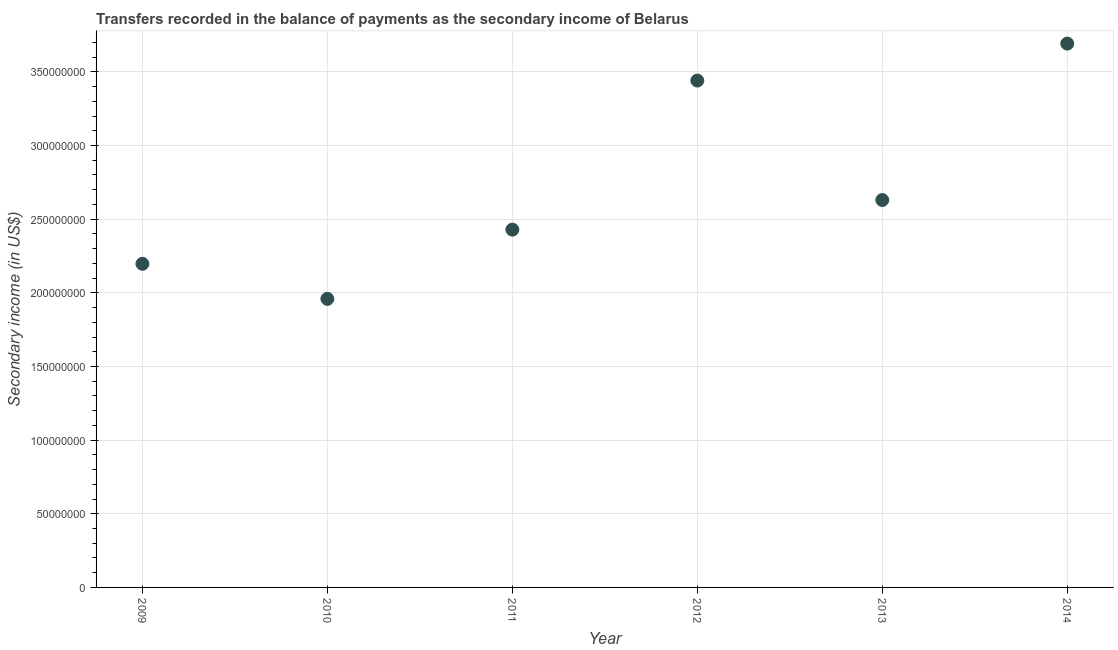What is the amount of secondary income in 2009?
Your answer should be compact. 2.20e+08. Across all years, what is the maximum amount of secondary income?
Give a very brief answer. 3.69e+08. Across all years, what is the minimum amount of secondary income?
Your answer should be compact. 1.96e+08. In which year was the amount of secondary income minimum?
Make the answer very short. 2010. What is the sum of the amount of secondary income?
Provide a short and direct response. 1.63e+09. What is the difference between the amount of secondary income in 2010 and 2011?
Offer a very short reply. -4.70e+07. What is the average amount of secondary income per year?
Your answer should be compact. 2.72e+08. What is the median amount of secondary income?
Provide a short and direct response. 2.53e+08. What is the ratio of the amount of secondary income in 2009 to that in 2014?
Make the answer very short. 0.6. What is the difference between the highest and the second highest amount of secondary income?
Offer a very short reply. 2.51e+07. What is the difference between the highest and the lowest amount of secondary income?
Make the answer very short. 1.73e+08. Does the amount of secondary income monotonically increase over the years?
Give a very brief answer. No. How many years are there in the graph?
Offer a very short reply. 6. What is the difference between two consecutive major ticks on the Y-axis?
Offer a very short reply. 5.00e+07. Does the graph contain any zero values?
Make the answer very short. No. Does the graph contain grids?
Provide a short and direct response. Yes. What is the title of the graph?
Provide a short and direct response. Transfers recorded in the balance of payments as the secondary income of Belarus. What is the label or title of the X-axis?
Offer a very short reply. Year. What is the label or title of the Y-axis?
Keep it short and to the point. Secondary income (in US$). What is the Secondary income (in US$) in 2009?
Your answer should be compact. 2.20e+08. What is the Secondary income (in US$) in 2010?
Offer a terse response. 1.96e+08. What is the Secondary income (in US$) in 2011?
Your answer should be compact. 2.43e+08. What is the Secondary income (in US$) in 2012?
Provide a succinct answer. 3.44e+08. What is the Secondary income (in US$) in 2013?
Give a very brief answer. 2.63e+08. What is the Secondary income (in US$) in 2014?
Make the answer very short. 3.69e+08. What is the difference between the Secondary income (in US$) in 2009 and 2010?
Offer a terse response. 2.38e+07. What is the difference between the Secondary income (in US$) in 2009 and 2011?
Your answer should be very brief. -2.32e+07. What is the difference between the Secondary income (in US$) in 2009 and 2012?
Make the answer very short. -1.24e+08. What is the difference between the Secondary income (in US$) in 2009 and 2013?
Offer a very short reply. -4.33e+07. What is the difference between the Secondary income (in US$) in 2009 and 2014?
Offer a very short reply. -1.50e+08. What is the difference between the Secondary income (in US$) in 2010 and 2011?
Offer a terse response. -4.70e+07. What is the difference between the Secondary income (in US$) in 2010 and 2012?
Provide a succinct answer. -1.48e+08. What is the difference between the Secondary income (in US$) in 2010 and 2013?
Your response must be concise. -6.71e+07. What is the difference between the Secondary income (in US$) in 2010 and 2014?
Your response must be concise. -1.73e+08. What is the difference between the Secondary income (in US$) in 2011 and 2012?
Ensure brevity in your answer.  -1.01e+08. What is the difference between the Secondary income (in US$) in 2011 and 2013?
Keep it short and to the point. -2.01e+07. What is the difference between the Secondary income (in US$) in 2011 and 2014?
Give a very brief answer. -1.26e+08. What is the difference between the Secondary income (in US$) in 2012 and 2013?
Give a very brief answer. 8.11e+07. What is the difference between the Secondary income (in US$) in 2012 and 2014?
Your answer should be very brief. -2.51e+07. What is the difference between the Secondary income (in US$) in 2013 and 2014?
Your answer should be compact. -1.06e+08. What is the ratio of the Secondary income (in US$) in 2009 to that in 2010?
Your answer should be very brief. 1.12. What is the ratio of the Secondary income (in US$) in 2009 to that in 2011?
Offer a terse response. 0.9. What is the ratio of the Secondary income (in US$) in 2009 to that in 2012?
Keep it short and to the point. 0.64. What is the ratio of the Secondary income (in US$) in 2009 to that in 2013?
Make the answer very short. 0.83. What is the ratio of the Secondary income (in US$) in 2009 to that in 2014?
Your response must be concise. 0.59. What is the ratio of the Secondary income (in US$) in 2010 to that in 2011?
Provide a short and direct response. 0.81. What is the ratio of the Secondary income (in US$) in 2010 to that in 2012?
Offer a terse response. 0.57. What is the ratio of the Secondary income (in US$) in 2010 to that in 2013?
Your answer should be compact. 0.74. What is the ratio of the Secondary income (in US$) in 2010 to that in 2014?
Make the answer very short. 0.53. What is the ratio of the Secondary income (in US$) in 2011 to that in 2012?
Your answer should be compact. 0.71. What is the ratio of the Secondary income (in US$) in 2011 to that in 2013?
Ensure brevity in your answer.  0.92. What is the ratio of the Secondary income (in US$) in 2011 to that in 2014?
Keep it short and to the point. 0.66. What is the ratio of the Secondary income (in US$) in 2012 to that in 2013?
Ensure brevity in your answer.  1.31. What is the ratio of the Secondary income (in US$) in 2012 to that in 2014?
Your answer should be compact. 0.93. What is the ratio of the Secondary income (in US$) in 2013 to that in 2014?
Offer a very short reply. 0.71. 